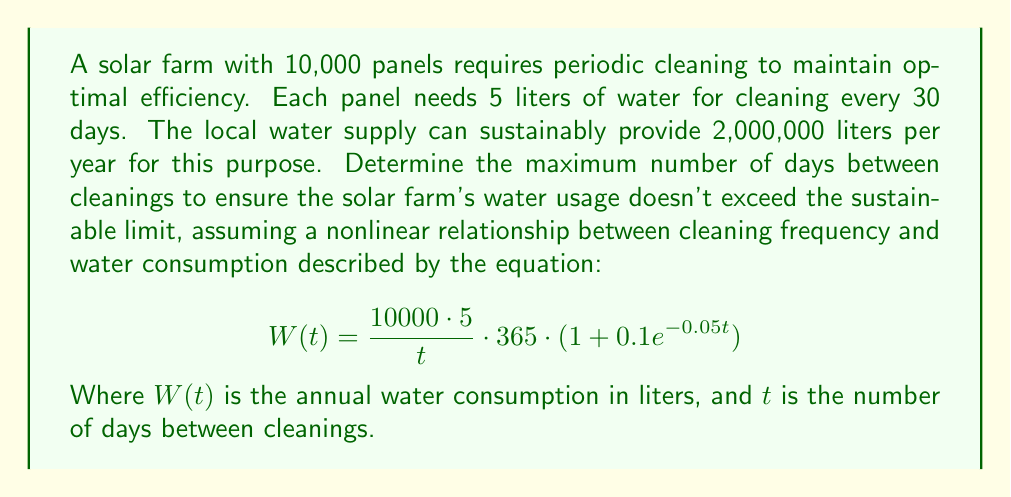Teach me how to tackle this problem. To solve this problem, we need to follow these steps:

1) First, we need to set up an equation based on the given information:
   $$W(t) = \frac{10000 \cdot 5}{t} \cdot 365 \cdot (1 + 0.1e^{-0.05t}) \leq 2000000$$

2) Simplify the left side of the inequality:
   $$\frac{18250000}{t} \cdot (1 + 0.1e^{-0.05t}) \leq 2000000$$

3) Multiply both sides by $t$:
   $$18250000 \cdot (1 + 0.1e^{-0.05t}) \leq 2000000t$$

4) Divide both sides by 2000000:
   $$9.125 \cdot (1 + 0.1e^{-0.05t}) \leq t$$

5) This nonlinear inequality doesn't have a straightforward analytical solution. We need to use numerical methods to solve it.

6) We can use the Newton-Raphson method to find the root of the function:
   $$f(t) = 9.125 \cdot (1 + 0.1e^{-0.05t}) - t$$

7) The derivative of this function is:
   $$f'(t) = -0.045625 \cdot e^{-0.05t} - 1$$

8) Starting with an initial guess of $t_0 = 30$, we can iterate:
   $$t_{n+1} = t_n - \frac{f(t_n)}{f'(t_n)}$$

9) After several iterations, this converges to approximately $t \approx 33.7$ days.

10) Since we need an integer number of days, we round down to ensure we don't exceed the water limit.
Answer: 33 days 